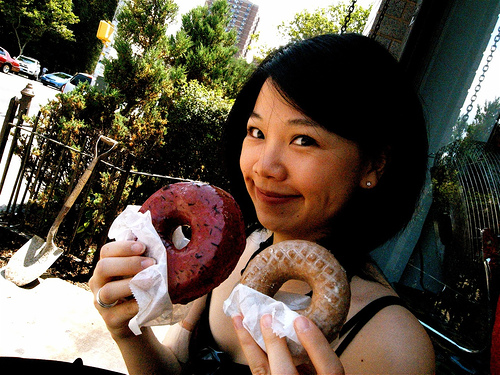Can you describe the setting of where this photo is taken? The photo appears to be taken outdoors, possibly on a city street given the presence of a street sign and metals bars, possibly a fence, in the background. The lighting and shadows suggest it might be a sunny day. 